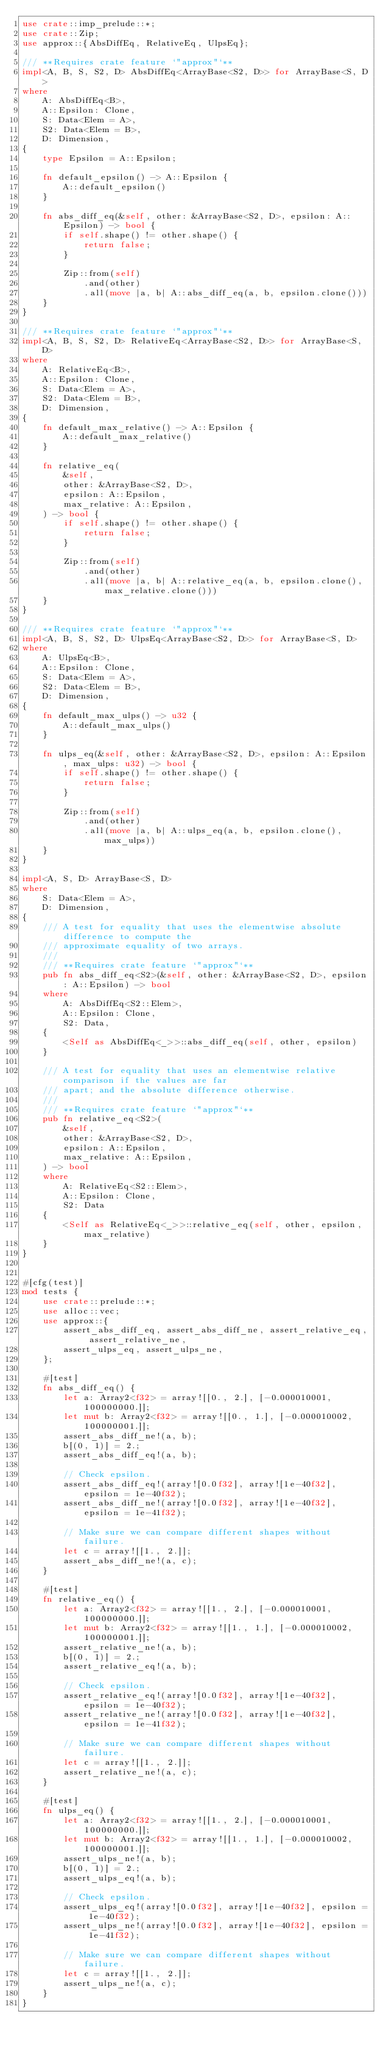<code> <loc_0><loc_0><loc_500><loc_500><_Rust_>use crate::imp_prelude::*;
use crate::Zip;
use approx::{AbsDiffEq, RelativeEq, UlpsEq};

/// **Requires crate feature `"approx"`**
impl<A, B, S, S2, D> AbsDiffEq<ArrayBase<S2, D>> for ArrayBase<S, D>
where
    A: AbsDiffEq<B>,
    A::Epsilon: Clone,
    S: Data<Elem = A>,
    S2: Data<Elem = B>,
    D: Dimension,
{
    type Epsilon = A::Epsilon;

    fn default_epsilon() -> A::Epsilon {
        A::default_epsilon()
    }

    fn abs_diff_eq(&self, other: &ArrayBase<S2, D>, epsilon: A::Epsilon) -> bool {
        if self.shape() != other.shape() {
            return false;
        }

        Zip::from(self)
            .and(other)
            .all(move |a, b| A::abs_diff_eq(a, b, epsilon.clone()))
    }
}

/// **Requires crate feature `"approx"`**
impl<A, B, S, S2, D> RelativeEq<ArrayBase<S2, D>> for ArrayBase<S, D>
where
    A: RelativeEq<B>,
    A::Epsilon: Clone,
    S: Data<Elem = A>,
    S2: Data<Elem = B>,
    D: Dimension,
{
    fn default_max_relative() -> A::Epsilon {
        A::default_max_relative()
    }

    fn relative_eq(
        &self,
        other: &ArrayBase<S2, D>,
        epsilon: A::Epsilon,
        max_relative: A::Epsilon,
    ) -> bool {
        if self.shape() != other.shape() {
            return false;
        }

        Zip::from(self)
            .and(other)
            .all(move |a, b| A::relative_eq(a, b, epsilon.clone(), max_relative.clone()))
    }
}

/// **Requires crate feature `"approx"`**
impl<A, B, S, S2, D> UlpsEq<ArrayBase<S2, D>> for ArrayBase<S, D>
where
    A: UlpsEq<B>,
    A::Epsilon: Clone,
    S: Data<Elem = A>,
    S2: Data<Elem = B>,
    D: Dimension,
{
    fn default_max_ulps() -> u32 {
        A::default_max_ulps()
    }

    fn ulps_eq(&self, other: &ArrayBase<S2, D>, epsilon: A::Epsilon, max_ulps: u32) -> bool {
        if self.shape() != other.shape() {
            return false;
        }

        Zip::from(self)
            .and(other)
            .all(move |a, b| A::ulps_eq(a, b, epsilon.clone(), max_ulps))
    }
}

impl<A, S, D> ArrayBase<S, D>
where
    S: Data<Elem = A>,
    D: Dimension,
{
    /// A test for equality that uses the elementwise absolute difference to compute the
    /// approximate equality of two arrays.
    ///
    /// **Requires crate feature `"approx"`**
    pub fn abs_diff_eq<S2>(&self, other: &ArrayBase<S2, D>, epsilon: A::Epsilon) -> bool
    where
        A: AbsDiffEq<S2::Elem>,
        A::Epsilon: Clone,
        S2: Data,
    {
        <Self as AbsDiffEq<_>>::abs_diff_eq(self, other, epsilon)
    }

    /// A test for equality that uses an elementwise relative comparison if the values are far
    /// apart; and the absolute difference otherwise.
    ///
    /// **Requires crate feature `"approx"`**
    pub fn relative_eq<S2>(
        &self,
        other: &ArrayBase<S2, D>,
        epsilon: A::Epsilon,
        max_relative: A::Epsilon,
    ) -> bool
    where
        A: RelativeEq<S2::Elem>,
        A::Epsilon: Clone,
        S2: Data
    {
        <Self as RelativeEq<_>>::relative_eq(self, other, epsilon, max_relative)
    }
}


#[cfg(test)]
mod tests {
    use crate::prelude::*;
    use alloc::vec;
    use approx::{
        assert_abs_diff_eq, assert_abs_diff_ne, assert_relative_eq, assert_relative_ne,
        assert_ulps_eq, assert_ulps_ne,
    };

    #[test]
    fn abs_diff_eq() {
        let a: Array2<f32> = array![[0., 2.], [-0.000010001, 100000000.]];
        let mut b: Array2<f32> = array![[0., 1.], [-0.000010002, 100000001.]];
        assert_abs_diff_ne!(a, b);
        b[(0, 1)] = 2.;
        assert_abs_diff_eq!(a, b);

        // Check epsilon.
        assert_abs_diff_eq!(array![0.0f32], array![1e-40f32], epsilon = 1e-40f32);
        assert_abs_diff_ne!(array![0.0f32], array![1e-40f32], epsilon = 1e-41f32);

        // Make sure we can compare different shapes without failure.
        let c = array![[1., 2.]];
        assert_abs_diff_ne!(a, c);
    }

    #[test]
    fn relative_eq() {
        let a: Array2<f32> = array![[1., 2.], [-0.000010001, 100000000.]];
        let mut b: Array2<f32> = array![[1., 1.], [-0.000010002, 100000001.]];
        assert_relative_ne!(a, b);
        b[(0, 1)] = 2.;
        assert_relative_eq!(a, b);

        // Check epsilon.
        assert_relative_eq!(array![0.0f32], array![1e-40f32], epsilon = 1e-40f32);
        assert_relative_ne!(array![0.0f32], array![1e-40f32], epsilon = 1e-41f32);

        // Make sure we can compare different shapes without failure.
        let c = array![[1., 2.]];
        assert_relative_ne!(a, c);
    }

    #[test]
    fn ulps_eq() {
        let a: Array2<f32> = array![[1., 2.], [-0.000010001, 100000000.]];
        let mut b: Array2<f32> = array![[1., 1.], [-0.000010002, 100000001.]];
        assert_ulps_ne!(a, b);
        b[(0, 1)] = 2.;
        assert_ulps_eq!(a, b);

        // Check epsilon.
        assert_ulps_eq!(array![0.0f32], array![1e-40f32], epsilon = 1e-40f32);
        assert_ulps_ne!(array![0.0f32], array![1e-40f32], epsilon = 1e-41f32);

        // Make sure we can compare different shapes without failure.
        let c = array![[1., 2.]];
        assert_ulps_ne!(a, c);
    }
}
</code> 